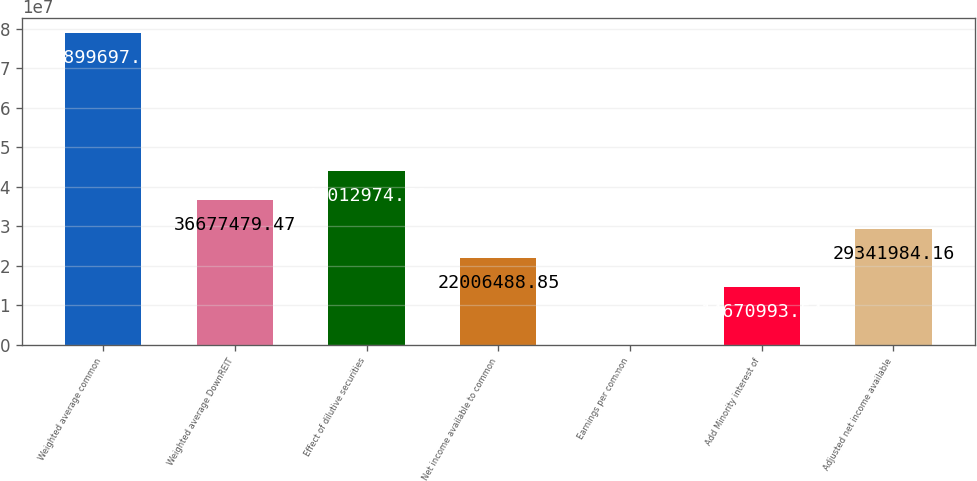Convert chart. <chart><loc_0><loc_0><loc_500><loc_500><bar_chart><fcel>Weighted average common<fcel>Weighted average DownREIT<fcel>Effect of dilutive securities<fcel>Net income available to common<fcel>Earnings per common<fcel>Add Minority interest of<fcel>Adjusted net income available<nl><fcel>7.88997e+07<fcel>3.66775e+07<fcel>4.4013e+07<fcel>2.20065e+07<fcel>2.92<fcel>1.4671e+07<fcel>2.9342e+07<nl></chart> 